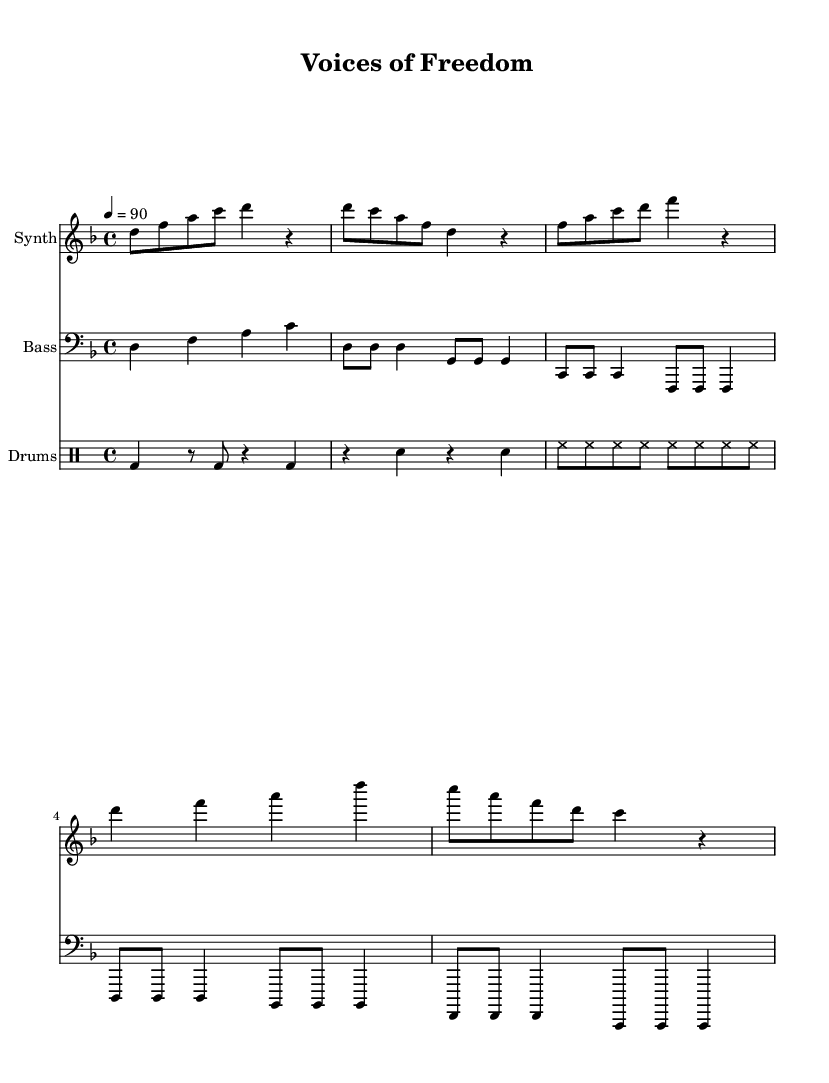What is the key signature of this music? The key signature is indicated at the beginning of the staff and shows two flats, which corresponds to the key of D minor.
Answer: D minor What is the time signature of this music? The time signature is found at the beginning of the staff, which shows a "4/4" indicating there are four beats per measure.
Answer: 4/4 What is the tempo marking of this piece? The tempo marking is indicated with "4 = 90" which specifies that the quarter note equals 90 beats per minute.
Answer: 90 How many measures are in the synth part? Counting the distinct segments divided by bar lines in the synth staff, there are six measures.
Answer: 6 What is the note duration of the first note in the bass part? The first note in the bass part is a quarter note represented by a filled black notehead on a stem, signifying it lasts for one beat.
Answer: Quarter note What type of rhythm does the drum pattern predominantly feature? The drum pattern primarily showcases a steady bass drum rhythm with alternating snare and hi-hat hits, typical in electronic music.
Answer: Electronic rhythm What is the instrument name for the staff with synthesizer music? The instrument name is found at the top of the corresponding staff, marking it as "Synth".
Answer: Synth 